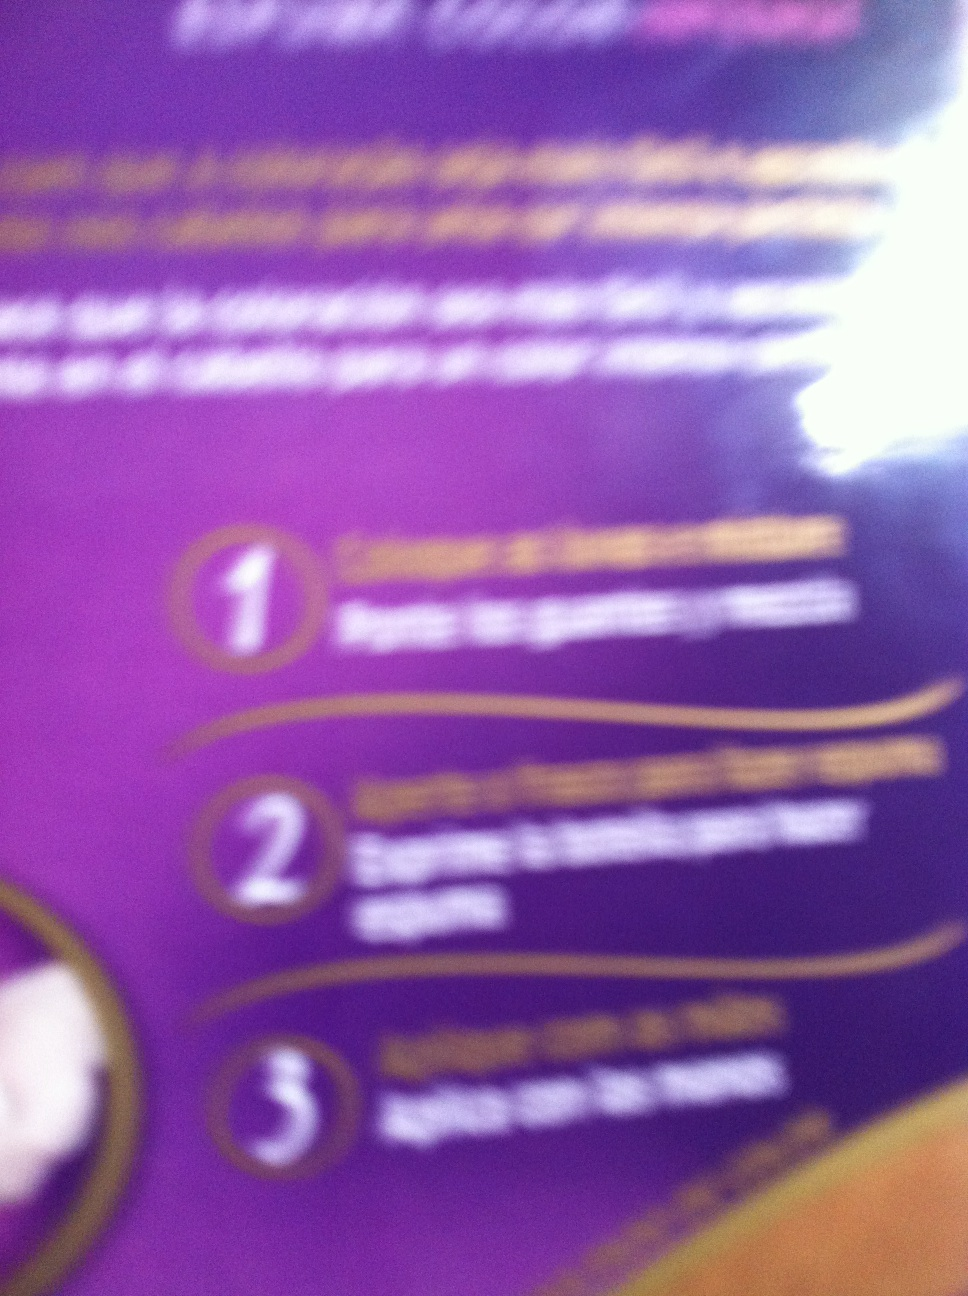Imagine this product turns you into a superhero! What would be your powers and adventures? Imagine applying this product and suddenly gaining the power of invincibility and perfect health. Each application could make you impervious to any harm and able to heal others with a touch. Your adventures would include traveling the world, protecting the innocent, and curing illnesses, becoming a beacon of hope and health for humanity! 